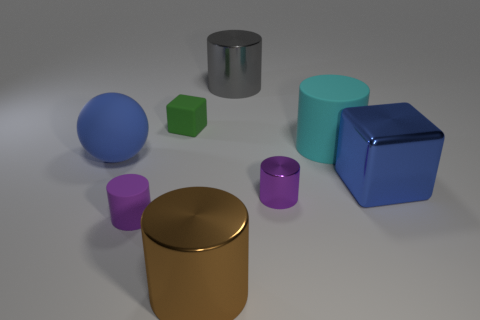Are there fewer cyan blocks than small metallic cylinders?
Keep it short and to the point. Yes. Is there a big blue matte thing that is right of the cyan object that is behind the blue matte ball?
Your answer should be compact. No. There is a small cylinder left of the big metallic cylinder behind the big rubber ball; is there a cylinder to the right of it?
Your answer should be very brief. Yes. There is a big blue thing to the right of the big matte cylinder; is its shape the same as the tiny matte object behind the big blue rubber thing?
Ensure brevity in your answer.  Yes. There is a big cube that is made of the same material as the large brown cylinder; what is its color?
Your answer should be very brief. Blue. Is the number of small purple cylinders behind the large cyan rubber cylinder less than the number of large things?
Offer a terse response. Yes. There is a metallic thing that is to the right of the purple metallic thing in front of the big shiny cylinder that is behind the big brown metallic object; what is its size?
Make the answer very short. Large. Are the big cylinder that is in front of the large matte sphere and the cyan object made of the same material?
Your response must be concise. No. There is a large object that is the same color as the big ball; what material is it?
Provide a succinct answer. Metal. Is there any other thing that has the same shape as the purple matte thing?
Your response must be concise. Yes. 